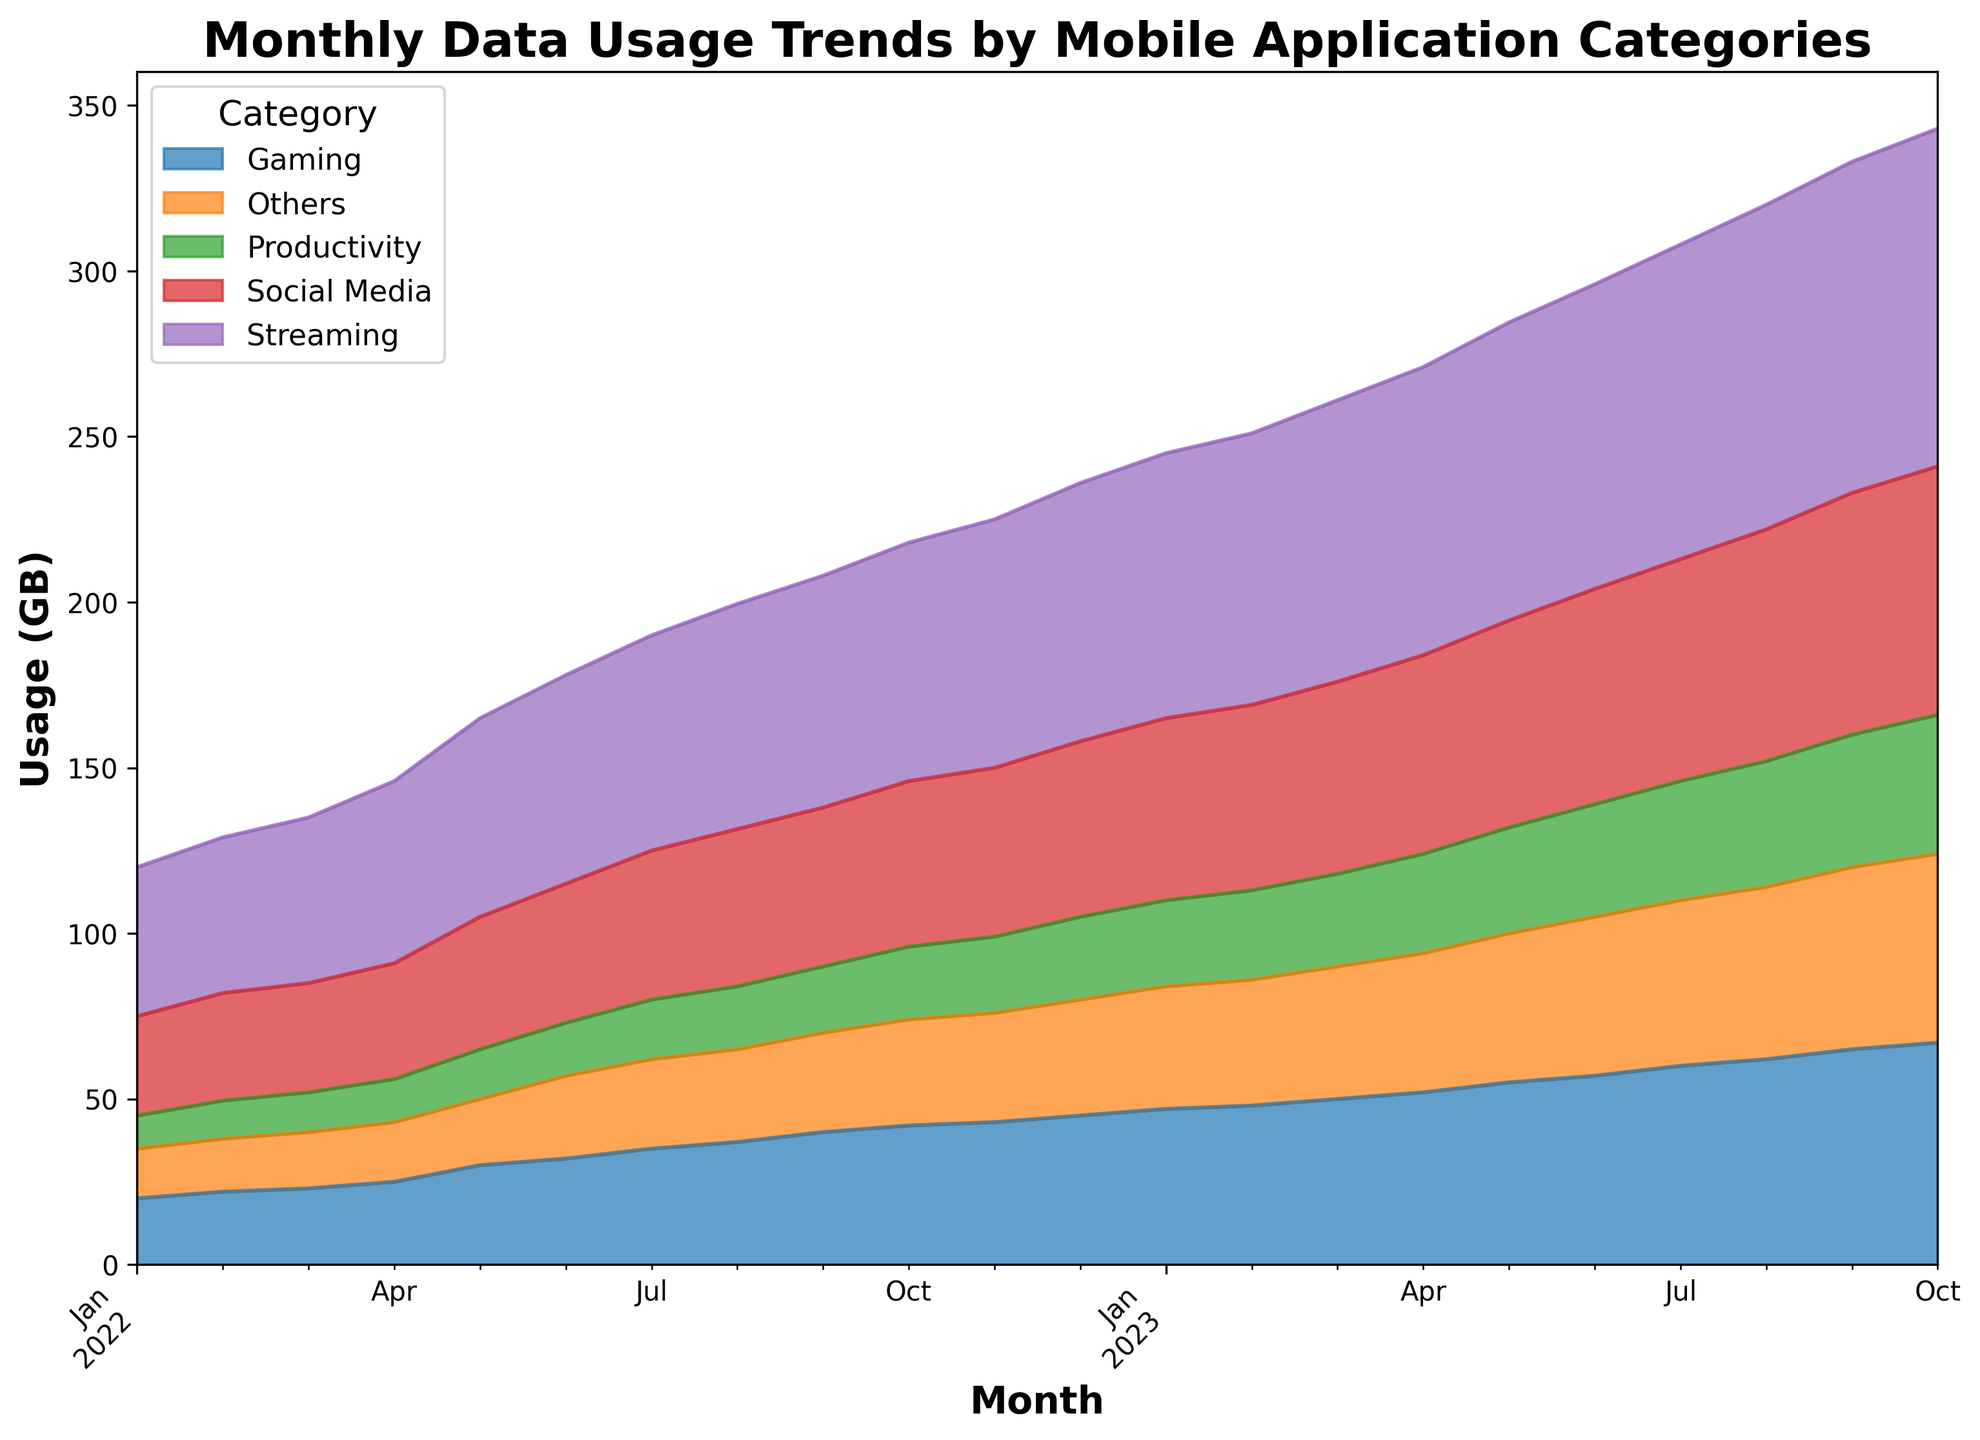What is the overall trend of data usage in the Streaming category? From January 2022 to October 2023, data usage in the Streaming category steadily increases each month, from 45 GB in January 2022 to 102 GB in October 2023.
Answer: Increases Which month saw the highest total data usage across all categories? To find the highest total data usage, sum the data usage for all categories in each month. The month with the highest total is October 2023, with a sum of 321 GB (75 + 102 + 67 + 42 + 57).
Answer: October 2023 Which category experienced the greatest increase in data usage from January 2022 to October 2023? By comparing the data usage in January 2022 and October 2023 for each category, Streaming had the greatest increase from 45 GB to 102 GB, an increase of 57 GB.
Answer: Streaming How did data usage in the Gaming and Productivity categories compare in June 2023? In June 2023, Gaming had 57 GB of data usage and Productivity had 34 GB. Gaming had higher usage than Productivity.
Answer: Gaming had higher usage What is the average data usage for the Social Media category over the entire period? Sum all the data usage values for Social Media from January 2022 to October 2023 and divide by the number of months (22). So, the total is 1090 GB, and the average is 1090 / 22 = 49.55 GB.
Answer: 49.55 GB How does the visual height of the areas for Social Media and Others categories compare in July 2022? Visually, the height of the Social Media area is greater than the height of the Others area in July 2022, indicating higher data usage in Social Media (45 GB vs. 27 GB).
Answer: Social Media is higher Which three categories had the least amount of data usage in January 2022, and what was the total combined usage for these categories? In January 2022, Productivity (10 GB), Others (15 GB), and Gaming (20 GB) had the least data usage. Combined, their usage is 10 + 15 + 20 = 45 GB.
Answer: Productivity, Others, Gaming; 45 GB Between what time periods did the Social Media category see the most significant monthly increase? The most significant increase for Social Media occurred between August 2023 (70 GB) and September 2023 (73 GB), an increase of 3 GB.
Answer: August 2023 to September 2023 What was the sum of data usage for all categories in March 2023? Sum the data usage in March 2023 for all categories: Social Media (58 GB), Streaming (85 GB), Gaming (50 GB), Productivity (28 GB), and Others (40 GB). Total = 58 + 85 + 50 + 28 + 40 = 261 GB.
Answer: 261 GB Which category showed a continuous increase in data usage without any decline from January 2022 to October 2023? By looking at the trends in the area chart, Streaming showed a continuous increase in usage every single month without declines.
Answer: Streaming 